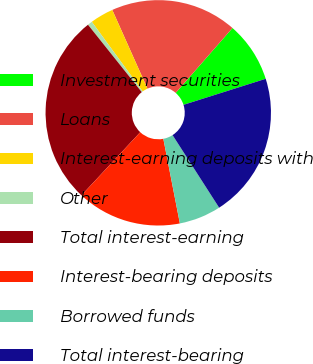Convert chart to OTSL. <chart><loc_0><loc_0><loc_500><loc_500><pie_chart><fcel>Investment securities<fcel>Loans<fcel>Interest-earning deposits with<fcel>Other<fcel>Total interest-earning<fcel>Interest-bearing deposits<fcel>Borrowed funds<fcel>Total interest-bearing<nl><fcel>8.68%<fcel>18.13%<fcel>3.35%<fcel>0.68%<fcel>27.35%<fcel>15.0%<fcel>6.01%<fcel>20.8%<nl></chart> 